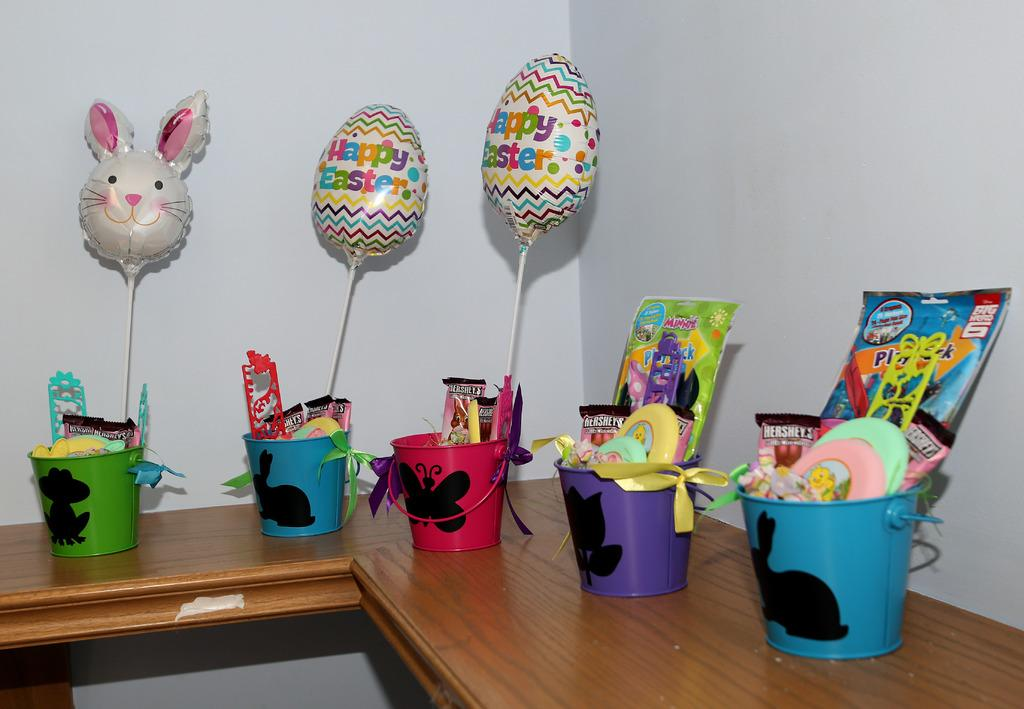What objects are present in the image? There are small buckets in the image. What are the buckets filled with? The buckets contain toys and air balloons. What type of gold can be seen in the image? There is no gold present in the image; it features small buckets containing toys and air balloons. 